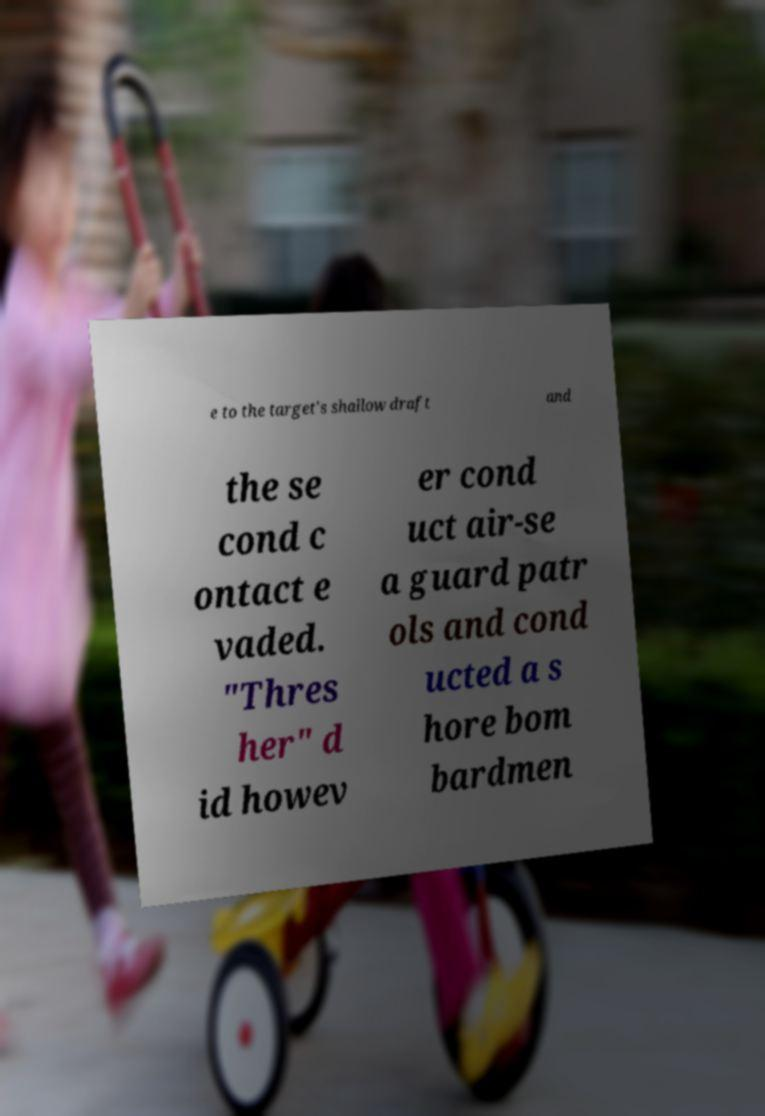Can you accurately transcribe the text from the provided image for me? e to the target's shallow draft and the se cond c ontact e vaded. "Thres her" d id howev er cond uct air-se a guard patr ols and cond ucted a s hore bom bardmen 